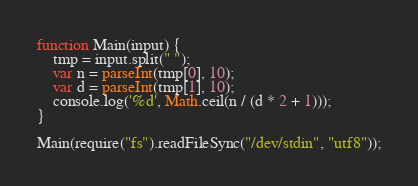Convert code to text. <code><loc_0><loc_0><loc_500><loc_500><_JavaScript_>function Main(input) {
	tmp = input.split(" ");
	var n = parseInt(tmp[0], 10);
	var d = parseInt(tmp[1], 10);
	console.log('%d', Math.ceil(n / (d * 2 + 1)));
}

Main(require("fs").readFileSync("/dev/stdin", "utf8"));</code> 